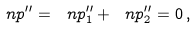Convert formula to latex. <formula><loc_0><loc_0><loc_500><loc_500>\ n p ^ { \prime \prime } = \ n p _ { 1 } ^ { \prime \prime } + \ n p _ { 2 } ^ { \prime \prime } = 0 \, ,</formula> 